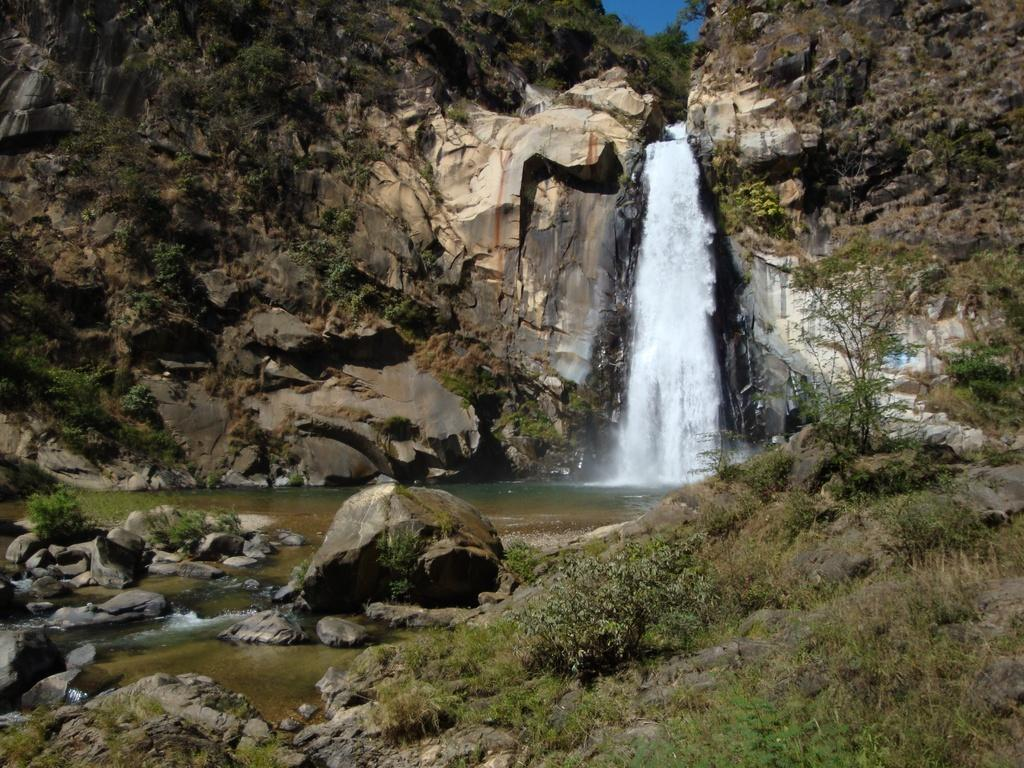What is the main feature in the center of the image? There is a waterfall in the center of the image. What can be seen at the bottom of the image? Rocks and grass are present at the bottom of the image. What is visible in the background of the image? There are hills and the sky in the background of the image. How many chickens are seen kicking water in the image? There are no chickens or any kicking activity present in the image. 